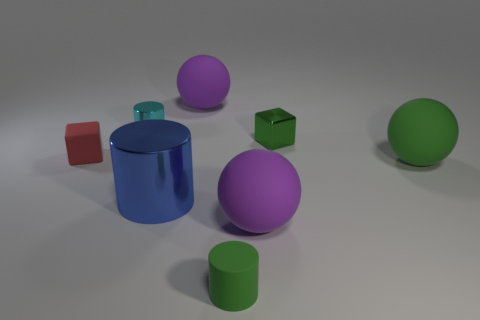Subtract all blue cylinders. How many purple spheres are left? 2 Subtract all small green matte cylinders. How many cylinders are left? 2 Subtract 1 cylinders. How many cylinders are left? 2 Add 2 big brown shiny balls. How many objects exist? 10 Subtract all blocks. How many objects are left? 6 Subtract all brown cylinders. Subtract all cyan cubes. How many cylinders are left? 3 Add 4 small cyan metallic things. How many small cyan metallic things are left? 5 Add 5 green rubber things. How many green rubber things exist? 7 Subtract 0 yellow cylinders. How many objects are left? 8 Subtract all large metal things. Subtract all small green blocks. How many objects are left? 6 